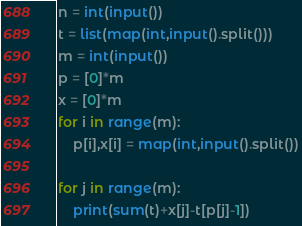Convert code to text. <code><loc_0><loc_0><loc_500><loc_500><_Python_>n = int(input())
t = list(map(int,input().split()))
m = int(input())
p = [0]*m
x = [0]*m
for i in range(m):
    p[i],x[i] = map(int,input().split())

for j in range(m):
    print(sum(t)+x[j]-t[p[j]-1])</code> 